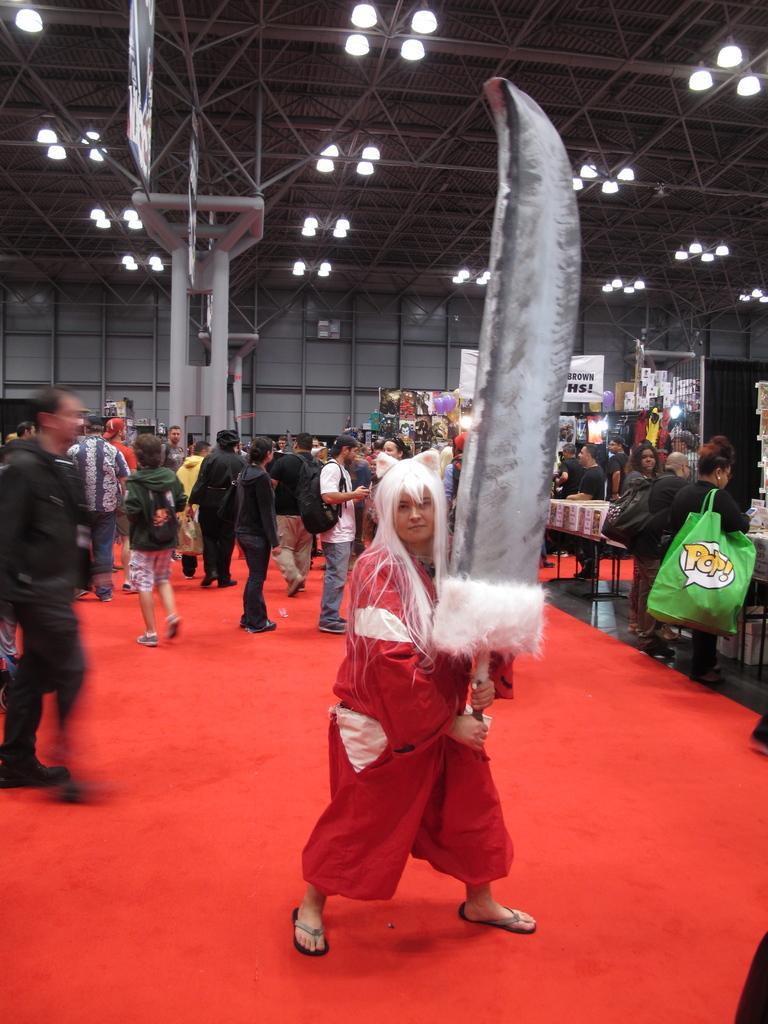Could you give a brief overview of what you see in this image? In this image there is a red color carpet. There are chairs. There are people. There are iron rods. There is a big knife. 